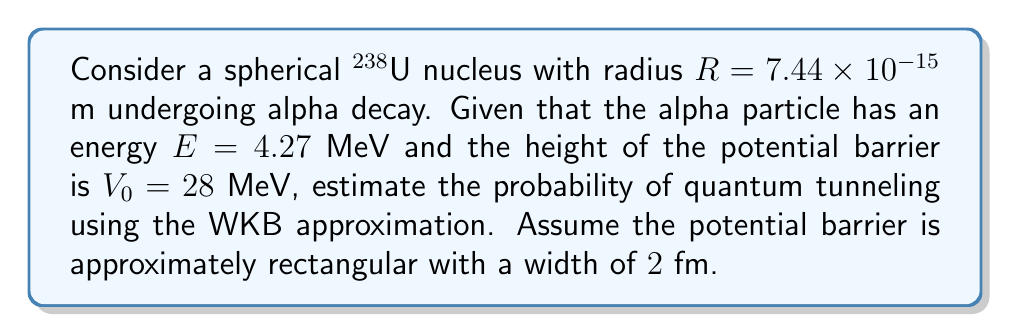Show me your answer to this math problem. To estimate the probability of quantum tunneling in alpha decay, we'll use the WKB (Wentzel-Kramers-Brillouin) approximation. This method is suitable for a nuclear physicist familiar with traditional atomic theories but open to quantum concepts.

Step 1: Calculate the wave number $k$ inside the barrier.
$$k = \sqrt{\frac{2m(V_0 - E)}{\hbar^2}}$$
where $m$ is the mass of the alpha particle, $V_0$ is the barrier height, and $E$ is the alpha particle energy.

Step 2: Determine the transmission coefficient $T$ using the WKB approximation.
$$T \approx e^{-2\int_a^b k(x)dx}$$
For a rectangular barrier of width $L$, this simplifies to:
$$T \approx e^{-2kL}$$

Step 3: Calculate the mass of the alpha particle.
$m_\alpha = 4 \times 1.66054 \times 10^{-27}$ kg $= 6.64216 \times 10^{-27}$ kg

Step 4: Convert energies to Joules.
$E = 4.27 \text{ MeV} = 6.84 \times 10^{-13}$ J
$V_0 = 28 \text{ MeV} = 4.48 \times 10^{-12}$ J

Step 5: Calculate $k$.
$$k = \sqrt{\frac{2 \times 6.64216 \times 10^{-27} \times (4.48 \times 10^{-12} - 6.84 \times 10^{-13})}{(1.05457 \times 10^{-34})^2}} = 2.92 \times 10^{20} \text{ m}^{-1}$$

Step 6: Calculate the transmission coefficient $T$.
$$T \approx e^{-2 \times 2.92 \times 10^{20} \times 2 \times 10^{-15}} = e^{-1168} \approx 4.16 \times 10^{-508}$$

The probability of quantum tunneling is equal to the transmission coefficient $T$.
Answer: $4.16 \times 10^{-508}$ 